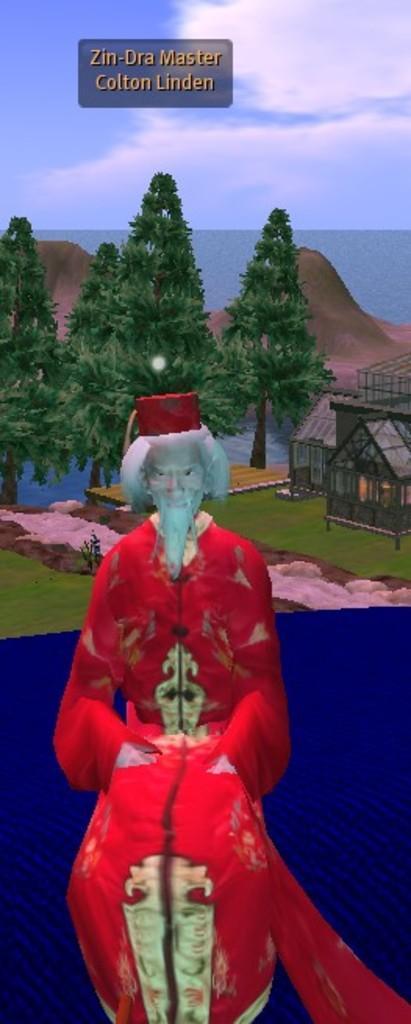Please provide a concise description of this image. Here we can see an animated picture, we can see a person here, there are some trees and water here, we can see the sky at the top of the picture, there is some text here. 